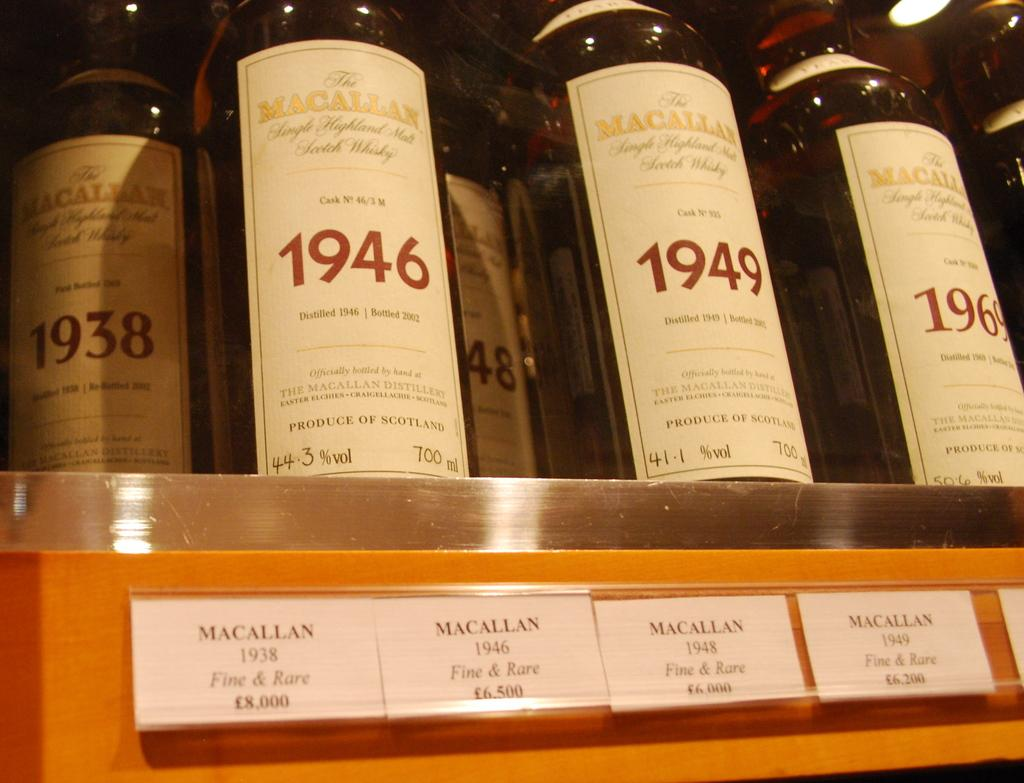<image>
Provide a brief description of the given image. All of the bottles of liquor are made by MaCallan. 